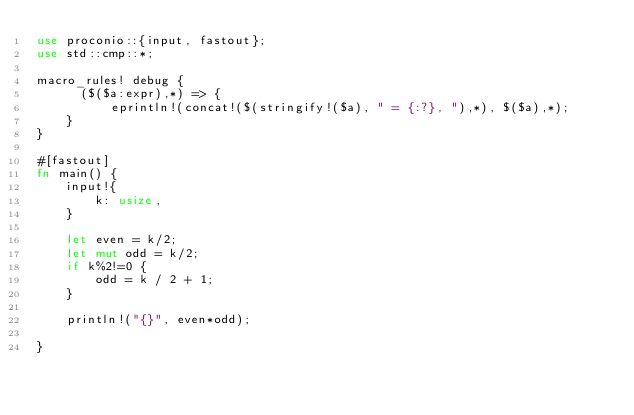Convert code to text. <code><loc_0><loc_0><loc_500><loc_500><_Rust_>use proconio::{input, fastout};
use std::cmp::*;

macro_rules! debug {
      ($($a:expr),*) => {
          eprintln!(concat!($(stringify!($a), " = {:?}, "),*), $($a),*);
    }
}

#[fastout]
fn main() {
    input!{
        k: usize,
    }

    let even = k/2;
    let mut odd = k/2;
    if k%2!=0 {
        odd = k / 2 + 1;
    }

    println!("{}", even*odd);

}
</code> 